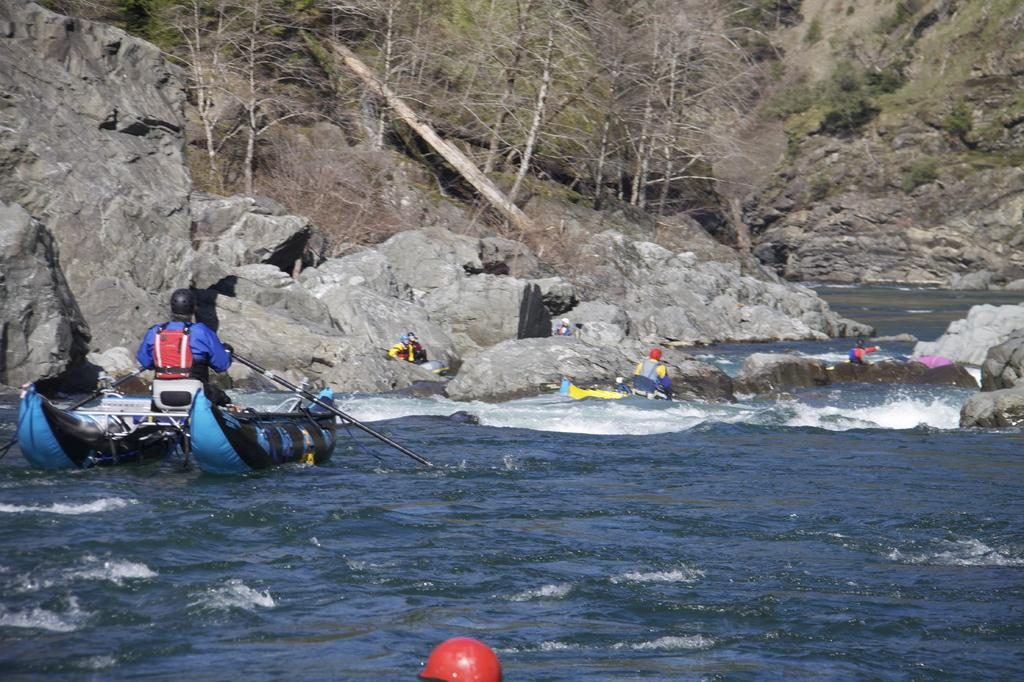What is the main feature of the image? There is a water body in the image. What are the people in the image doing? People are boating on the water body. What can be seen on the left side of the image? There are mountains on the left side of the image. What type of vegetation is present in the image? Trees are present in the image. How many crates of apples can be seen in the image? There are no crates of apples present in the image. What type of cough is the person in the image experiencing? There is no person in the image experiencing a cough. 